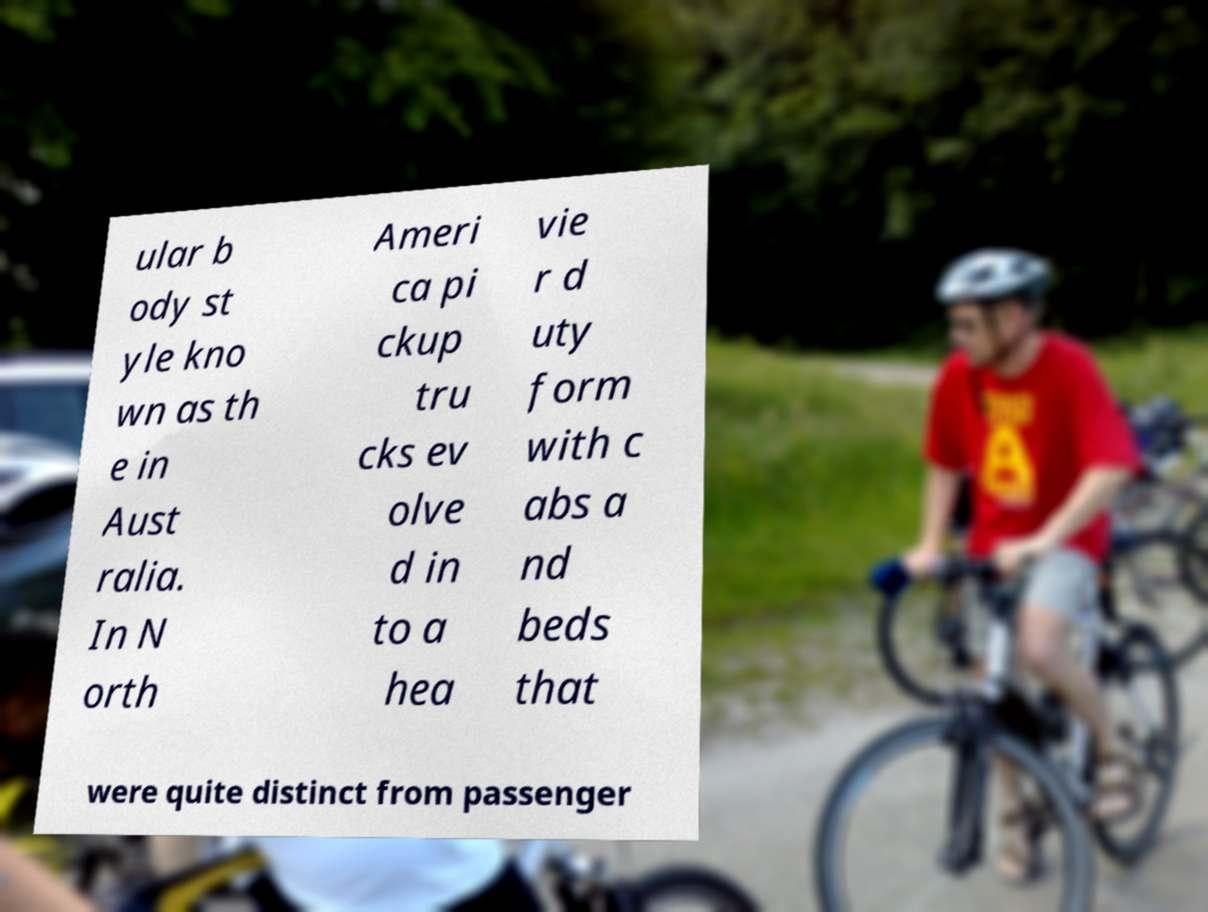For documentation purposes, I need the text within this image transcribed. Could you provide that? ular b ody st yle kno wn as th e in Aust ralia. In N orth Ameri ca pi ckup tru cks ev olve d in to a hea vie r d uty form with c abs a nd beds that were quite distinct from passenger 